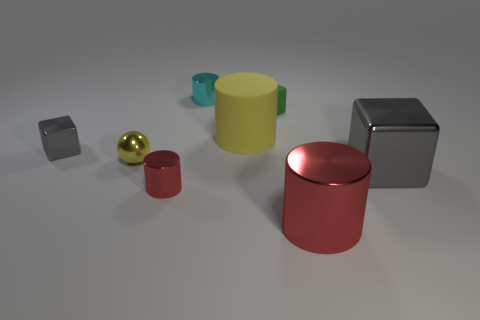What number of other things are there of the same shape as the big matte thing?
Provide a succinct answer. 3. What is the size of the cyan thing?
Your answer should be compact. Small. How many objects are large metallic blocks or big yellow things?
Provide a succinct answer. 2. What size is the gray block that is to the left of the small yellow sphere?
Offer a terse response. Small. Are there any other things that have the same size as the ball?
Give a very brief answer. Yes. There is a cube that is both right of the tiny shiny cube and in front of the large rubber thing; what is its color?
Give a very brief answer. Gray. Are the tiny cylinder that is behind the metallic ball and the small red thing made of the same material?
Provide a succinct answer. Yes. Do the small matte thing and the block that is in front of the tiny gray metal thing have the same color?
Make the answer very short. No. Are there any small matte objects in front of the big cube?
Make the answer very short. No. There is a block left of the yellow ball; does it have the same size as the gray block that is on the right side of the tiny yellow ball?
Your answer should be very brief. No. 